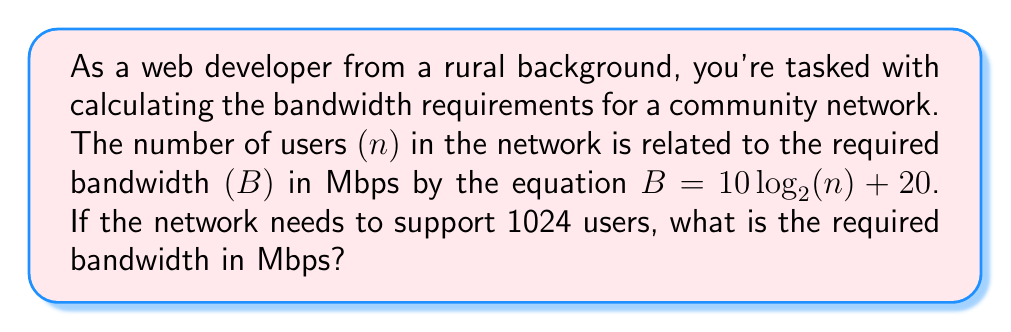Can you answer this question? To solve this problem, we'll follow these steps:

1) We're given the equation: $B = 10 \log_2(n) + 20$
   Where B is the bandwidth in Mbps and n is the number of users.

2) We know that n = 1024 users. Let's substitute this into our equation:

   $B = 10 \log_2(1024) + 20$

3) Now, let's simplify the logarithm. Remember, $1024 = 2^{10}$, so:

   $B = 10 \log_2(2^{10}) + 20$

4) A property of logarithms states that $\log_a(a^x) = x$, so:

   $B = 10 \cdot 10 + 20$

5) Simplify:

   $B = 100 + 20 = 120$

Therefore, the required bandwidth is 120 Mbps.
Answer: 120 Mbps 